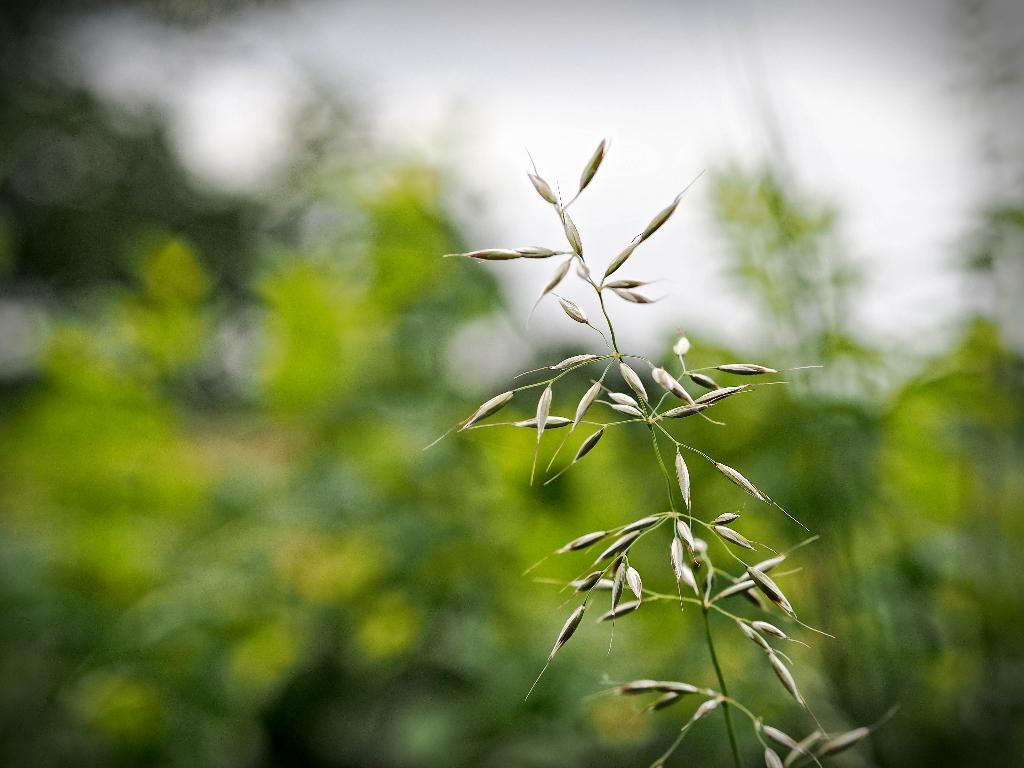What is present in the image? There is a plant in the image. Can you describe the background of the image? The background of the image is blurry. How many waves can be seen crashing on the shore in the image? There are no waves present in the image; it features a plant and a blurry background. 